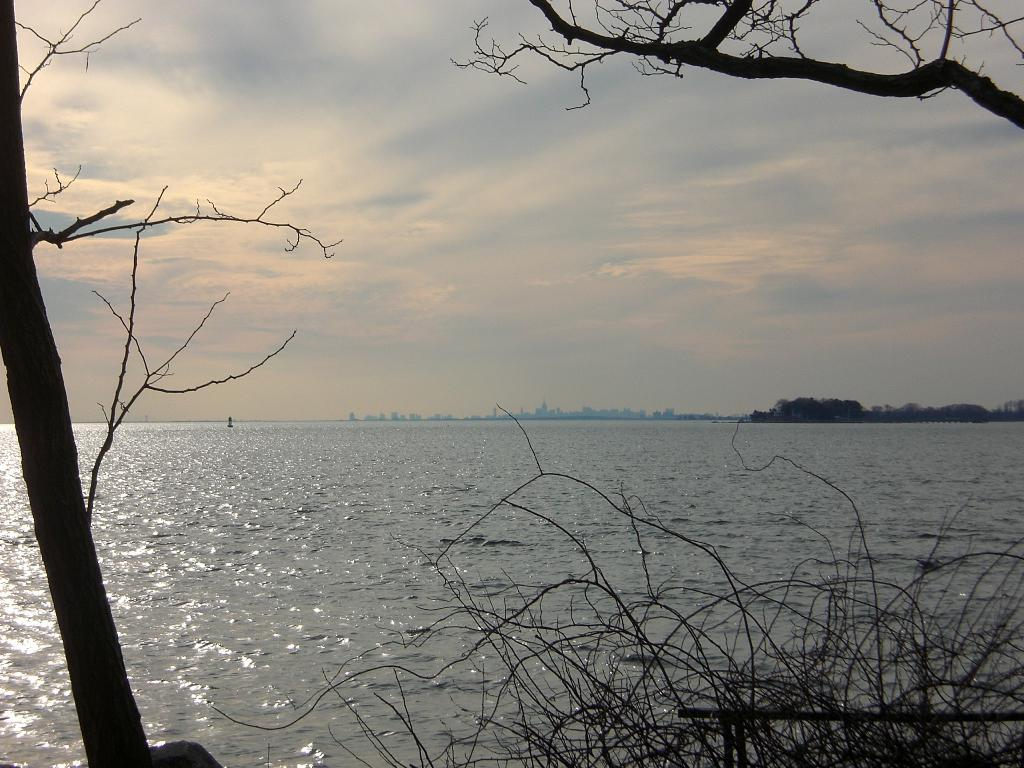What type of vegetation can be seen in the image? There are trees in the image. What natural element is visible in the image? There is water visible in the image. What can be seen in the sky in the image? There are clouds in the image. What type of salt can be seen on the sofa during the feast in the image? There is no salt, sofa, or feast present in the image. 